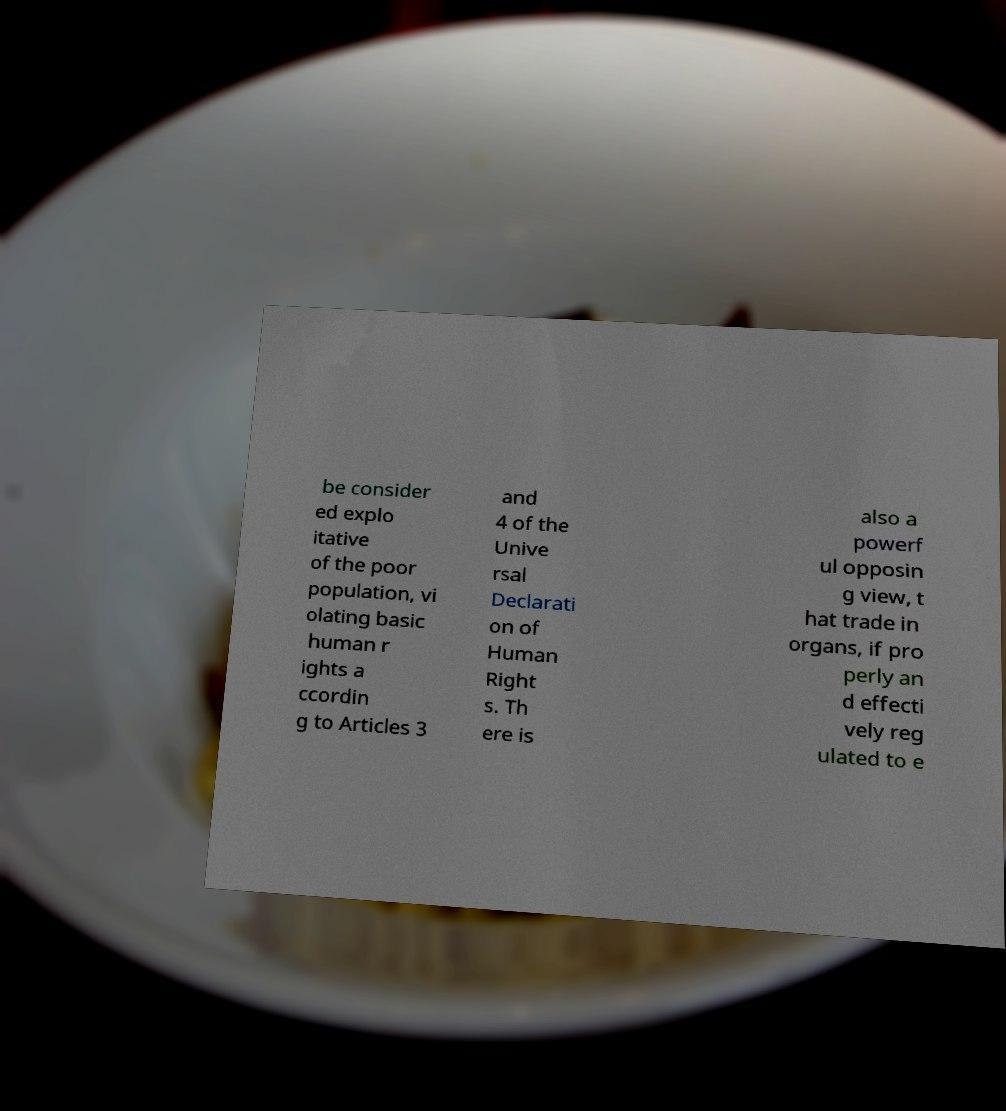There's text embedded in this image that I need extracted. Can you transcribe it verbatim? be consider ed explo itative of the poor population, vi olating basic human r ights a ccordin g to Articles 3 and 4 of the Unive rsal Declarati on of Human Right s. Th ere is also a powerf ul opposin g view, t hat trade in organs, if pro perly an d effecti vely reg ulated to e 